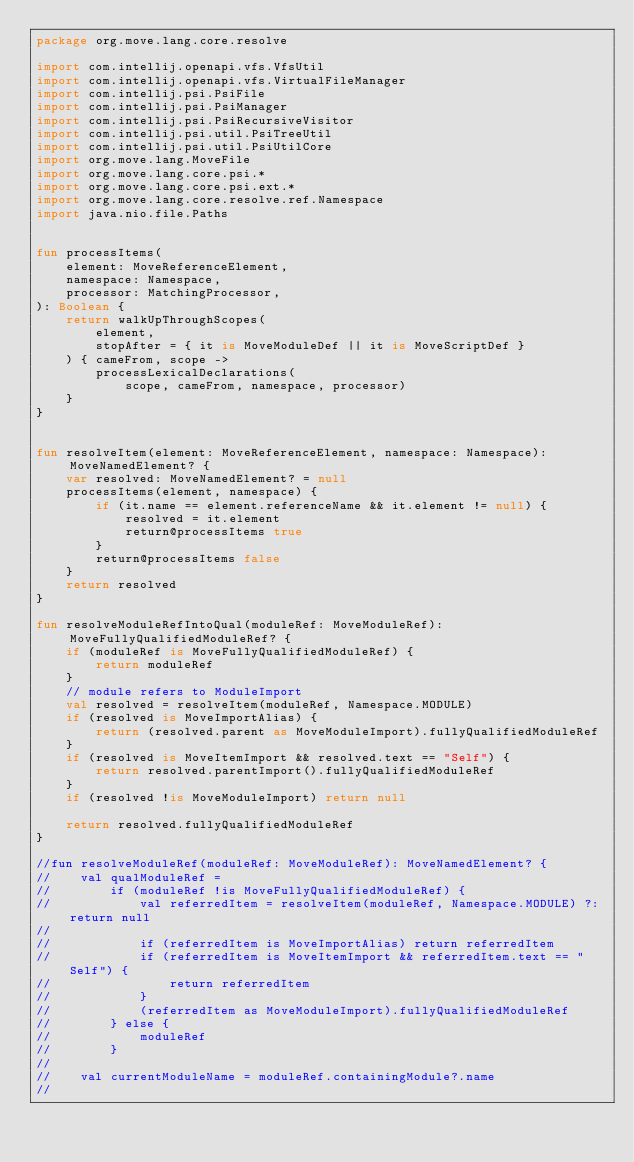<code> <loc_0><loc_0><loc_500><loc_500><_Kotlin_>package org.move.lang.core.resolve

import com.intellij.openapi.vfs.VfsUtil
import com.intellij.openapi.vfs.VirtualFileManager
import com.intellij.psi.PsiFile
import com.intellij.psi.PsiManager
import com.intellij.psi.PsiRecursiveVisitor
import com.intellij.psi.util.PsiTreeUtil
import com.intellij.psi.util.PsiUtilCore
import org.move.lang.MoveFile
import org.move.lang.core.psi.*
import org.move.lang.core.psi.ext.*
import org.move.lang.core.resolve.ref.Namespace
import java.nio.file.Paths


fun processItems(
    element: MoveReferenceElement,
    namespace: Namespace,
    processor: MatchingProcessor,
): Boolean {
    return walkUpThroughScopes(
        element,
        stopAfter = { it is MoveModuleDef || it is MoveScriptDef }
    ) { cameFrom, scope ->
        processLexicalDeclarations(
            scope, cameFrom, namespace, processor)
    }
}


fun resolveItem(element: MoveReferenceElement, namespace: Namespace): MoveNamedElement? {
    var resolved: MoveNamedElement? = null
    processItems(element, namespace) {
        if (it.name == element.referenceName && it.element != null) {
            resolved = it.element
            return@processItems true
        }
        return@processItems false
    }
    return resolved
}

fun resolveModuleRefIntoQual(moduleRef: MoveModuleRef): MoveFullyQualifiedModuleRef? {
    if (moduleRef is MoveFullyQualifiedModuleRef) {
        return moduleRef
    }
    // module refers to ModuleImport
    val resolved = resolveItem(moduleRef, Namespace.MODULE)
    if (resolved is MoveImportAlias) {
        return (resolved.parent as MoveModuleImport).fullyQualifiedModuleRef
    }
    if (resolved is MoveItemImport && resolved.text == "Self") {
        return resolved.parentImport().fullyQualifiedModuleRef
    }
    if (resolved !is MoveModuleImport) return null

    return resolved.fullyQualifiedModuleRef
}

//fun resolveModuleRef(moduleRef: MoveModuleRef): MoveNamedElement? {
//    val qualModuleRef =
//        if (moduleRef !is MoveFullyQualifiedModuleRef) {
//            val referredItem = resolveItem(moduleRef, Namespace.MODULE) ?: return null
//
//            if (referredItem is MoveImportAlias) return referredItem
//            if (referredItem is MoveItemImport && referredItem.text == "Self") {
//                return referredItem
//            }
//            (referredItem as MoveModuleImport).fullyQualifiedModuleRef
//        } else {
//            moduleRef
//        }
//
//    val currentModuleName = moduleRef.containingModule?.name
//</code> 